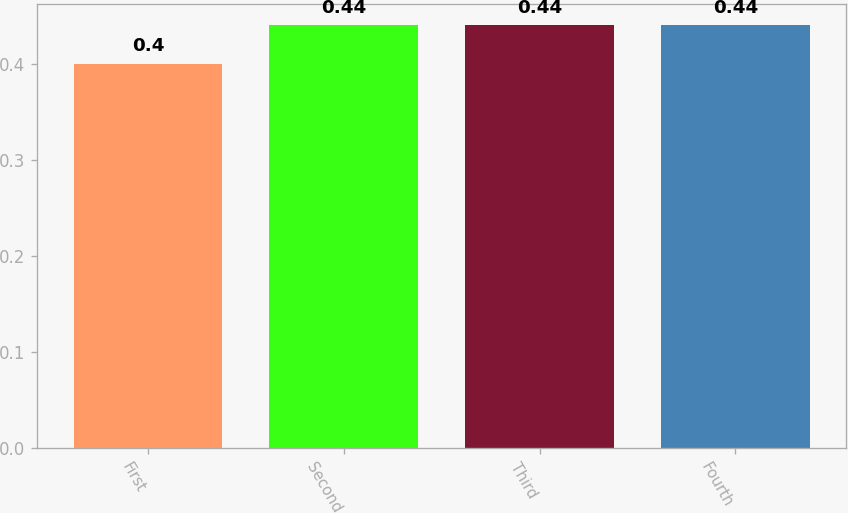Convert chart to OTSL. <chart><loc_0><loc_0><loc_500><loc_500><bar_chart><fcel>First<fcel>Second<fcel>Third<fcel>Fourth<nl><fcel>0.4<fcel>0.44<fcel>0.44<fcel>0.44<nl></chart> 